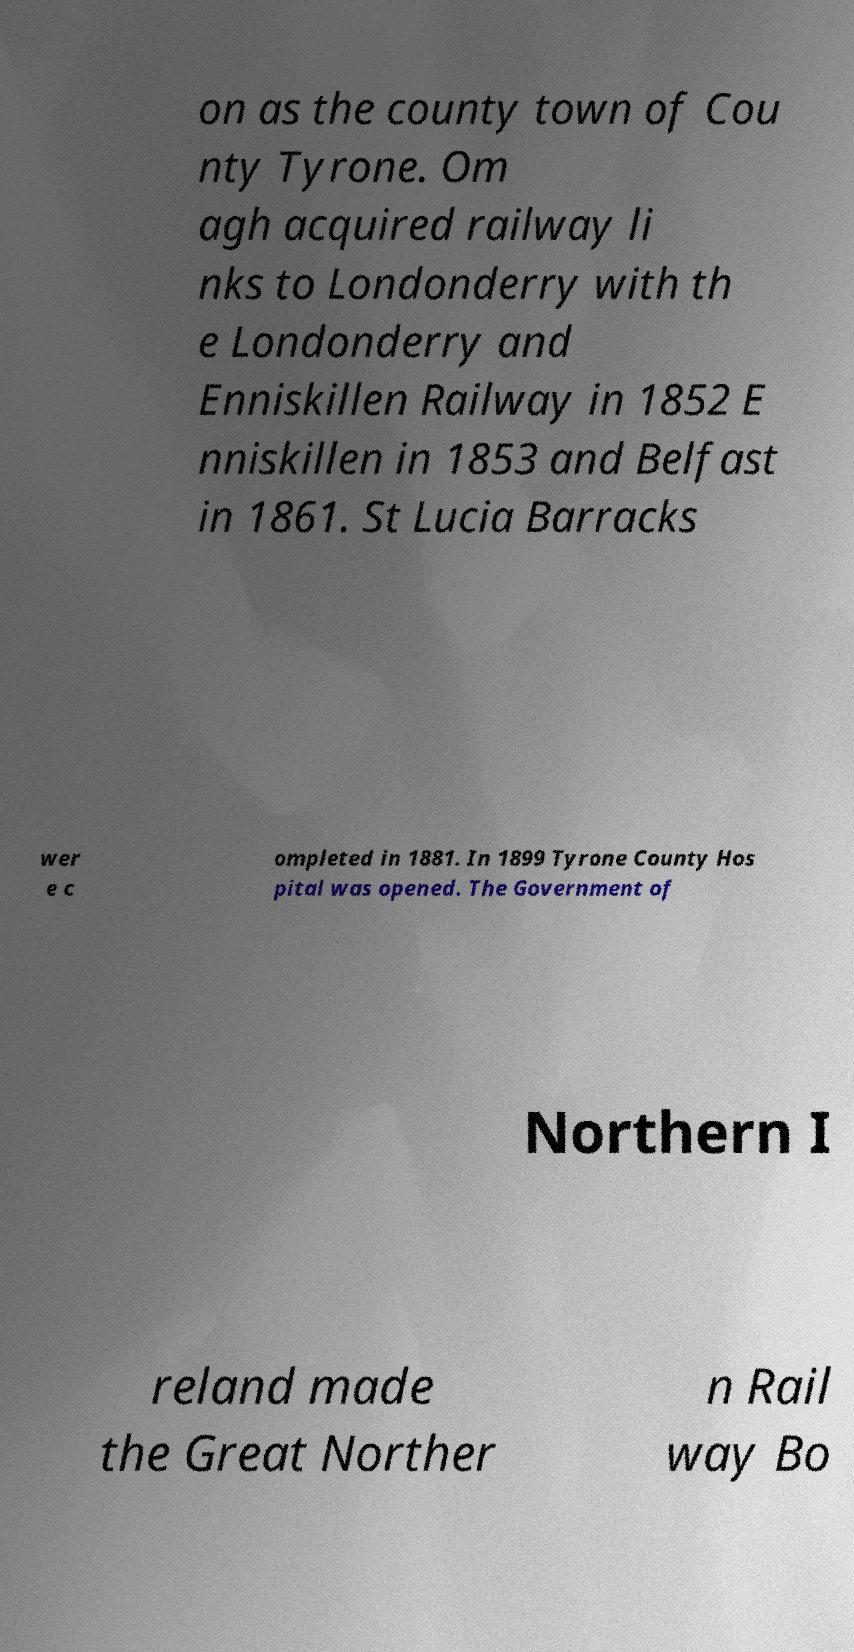For documentation purposes, I need the text within this image transcribed. Could you provide that? on as the county town of Cou nty Tyrone. Om agh acquired railway li nks to Londonderry with th e Londonderry and Enniskillen Railway in 1852 E nniskillen in 1853 and Belfast in 1861. St Lucia Barracks wer e c ompleted in 1881. In 1899 Tyrone County Hos pital was opened. The Government of Northern I reland made the Great Norther n Rail way Bo 